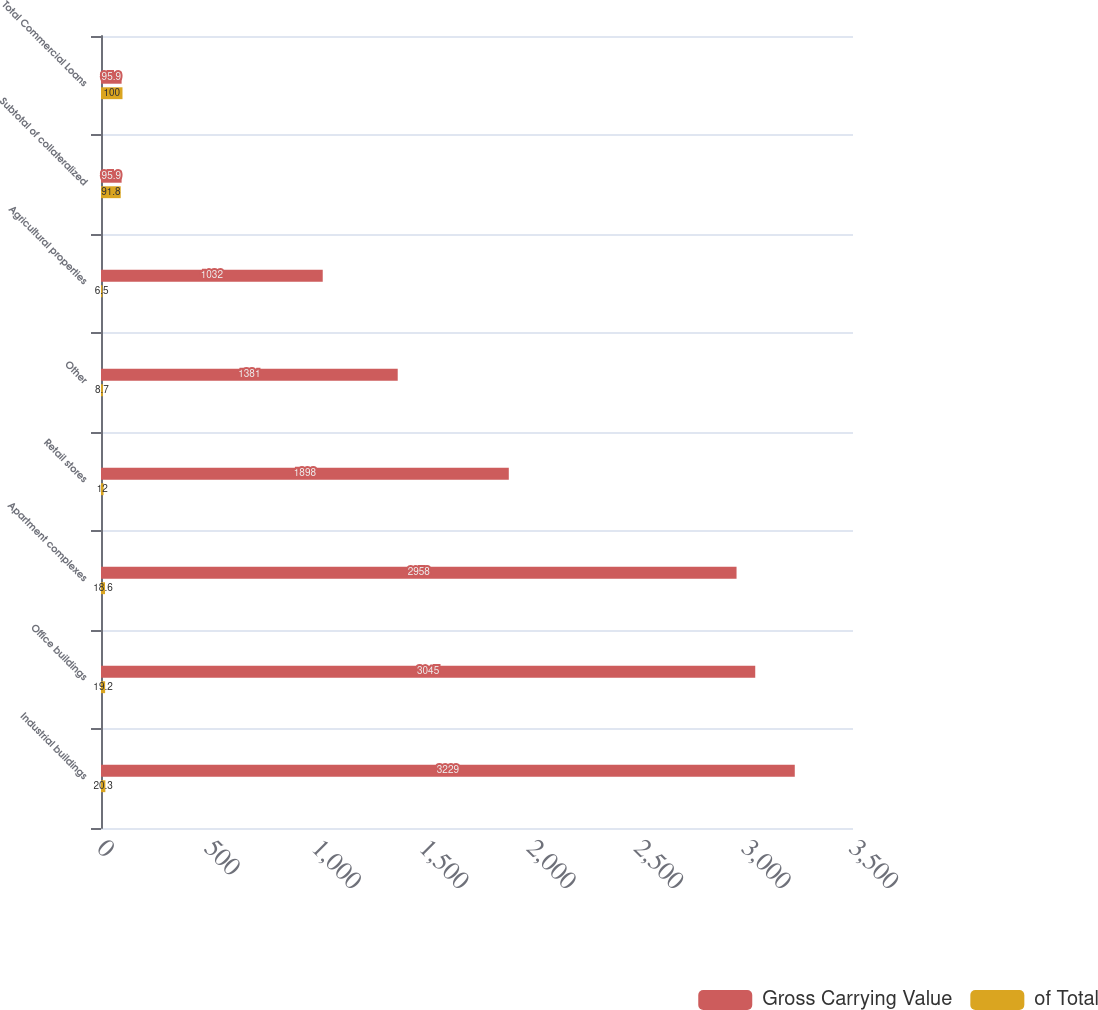Convert chart to OTSL. <chart><loc_0><loc_0><loc_500><loc_500><stacked_bar_chart><ecel><fcel>Industrial buildings<fcel>Office buildings<fcel>Apartment complexes<fcel>Retail stores<fcel>Other<fcel>Agricultural properties<fcel>Subtotal of collateralized<fcel>Total Commercial Loans<nl><fcel>Gross Carrying Value<fcel>3229<fcel>3045<fcel>2958<fcel>1898<fcel>1381<fcel>1032<fcel>95.9<fcel>95.9<nl><fcel>of Total<fcel>20.3<fcel>19.2<fcel>18.6<fcel>12<fcel>8.7<fcel>6.5<fcel>91.8<fcel>100<nl></chart> 